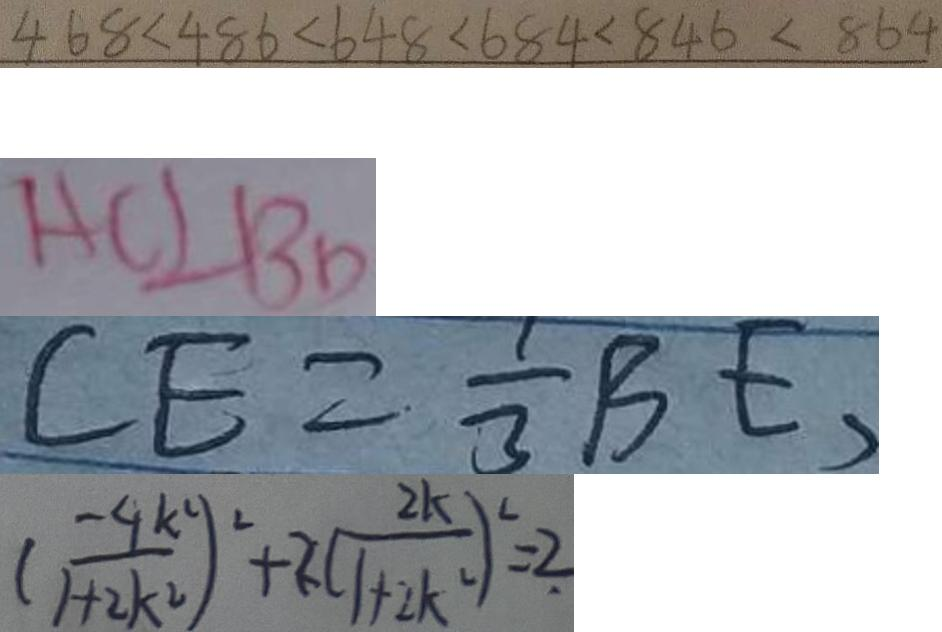<formula> <loc_0><loc_0><loc_500><loc_500>4 6 8 < 4 8 6 < 6 4 8 < 6 8 4 < 8 4 6 < 8 6 4 
 A C \bot B D 
 C E = \frac { 1 } { 3 } B E , 
 ( \frac { - 4 k ^ { 2 } } { 1 + 2 k ^ { 2 } } ) ^ { 2 } + 2 ( \frac { 2 k } { 1 + 2 k ^ { 2 } } ) ^ { 2 } = 2</formula> 